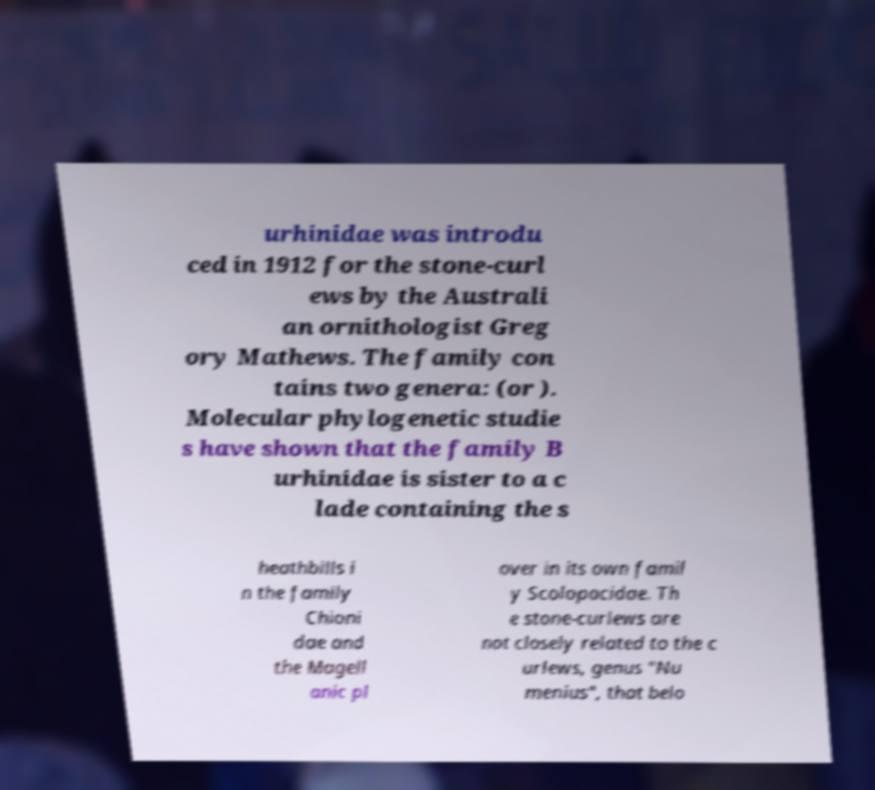Could you assist in decoding the text presented in this image and type it out clearly? urhinidae was introdu ced in 1912 for the stone-curl ews by the Australi an ornithologist Greg ory Mathews. The family con tains two genera: (or ). Molecular phylogenetic studie s have shown that the family B urhinidae is sister to a c lade containing the s heathbills i n the family Chioni dae and the Magell anic pl over in its own famil y Scolopacidae. Th e stone-curlews are not closely related to the c urlews, genus "Nu menius", that belo 